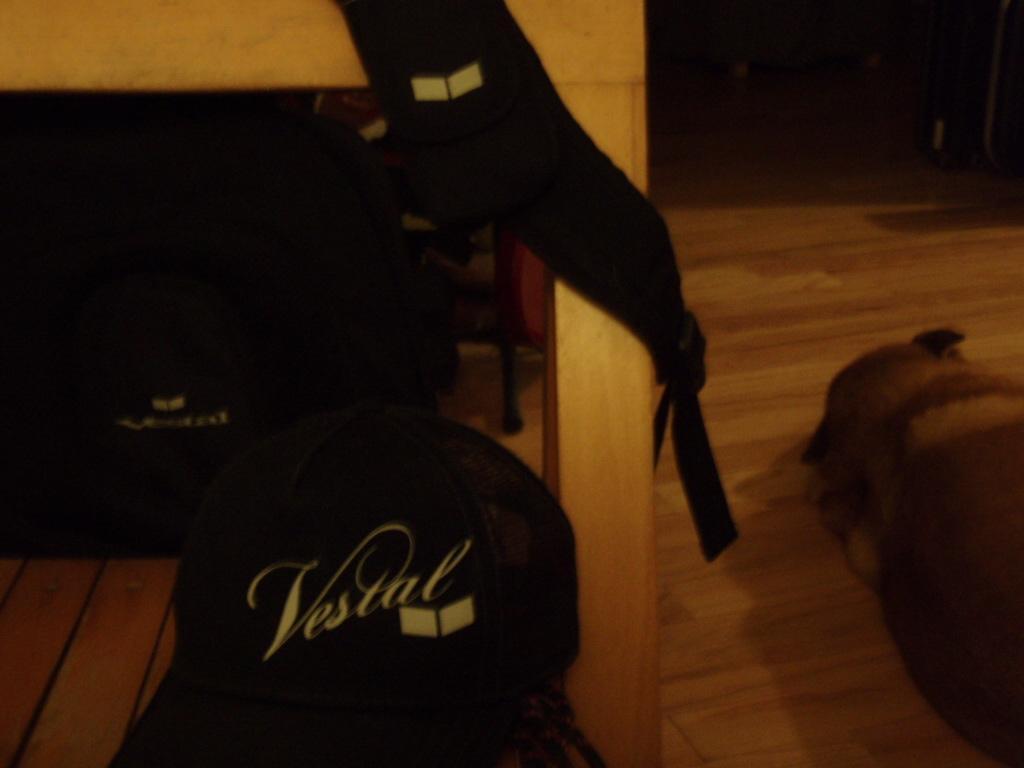Can you describe this image briefly? In this picture we can see a dog is laying on the floor, and we can find dark background. 